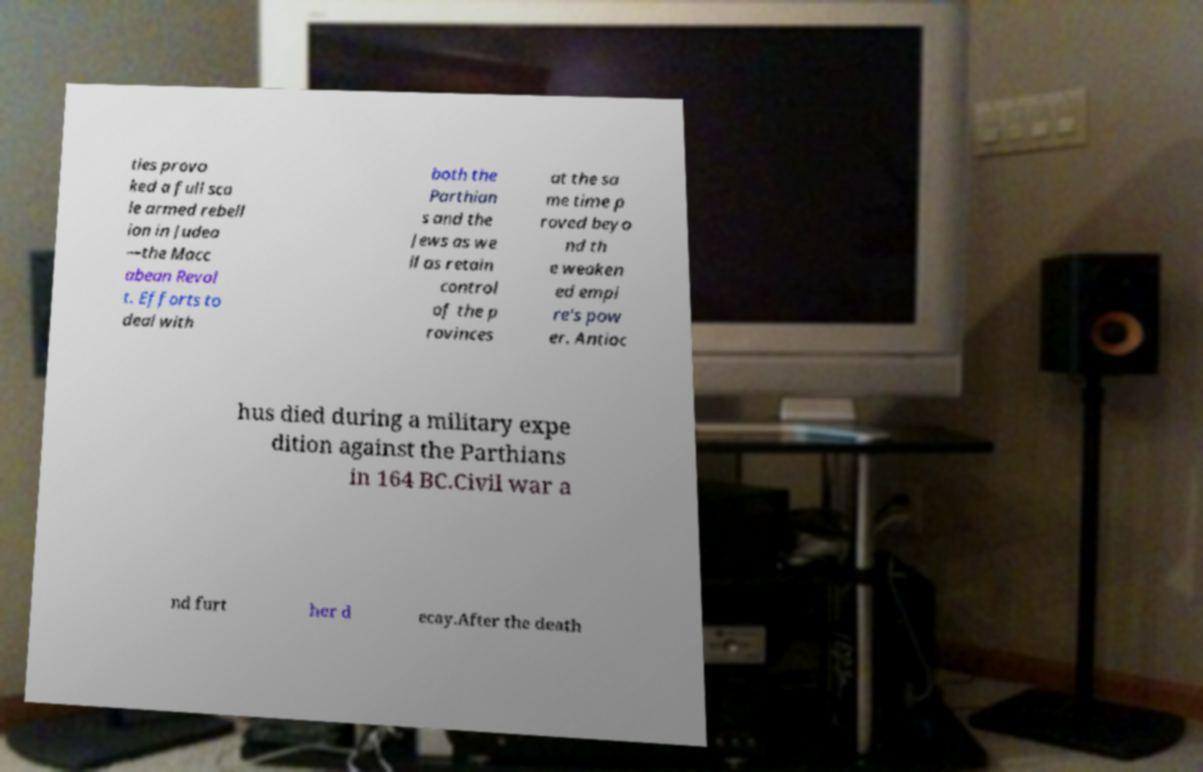Could you assist in decoding the text presented in this image and type it out clearly? ties provo ked a full sca le armed rebell ion in Judea —the Macc abean Revol t. Efforts to deal with both the Parthian s and the Jews as we ll as retain control of the p rovinces at the sa me time p roved beyo nd th e weaken ed empi re's pow er. Antioc hus died during a military expe dition against the Parthians in 164 BC.Civil war a nd furt her d ecay.After the death 